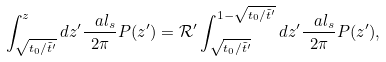<formula> <loc_0><loc_0><loc_500><loc_500>\int ^ { z } _ { \sqrt { t _ { 0 } / \tilde { t } ^ { \prime } } } d z ^ { \prime } \frac { \ a l _ { s } } { 2 \pi } P ( z ^ { \prime } ) = \mathcal { R } ^ { \prime } \int ^ { 1 - { \sqrt { t _ { 0 } / \tilde { t } ^ { \prime } } } } _ { \sqrt { t _ { 0 } / \tilde { t } ^ { \prime } } } d z ^ { \prime } \frac { \ a l _ { s } } { 2 \pi } P ( z ^ { \prime } ) ,</formula> 